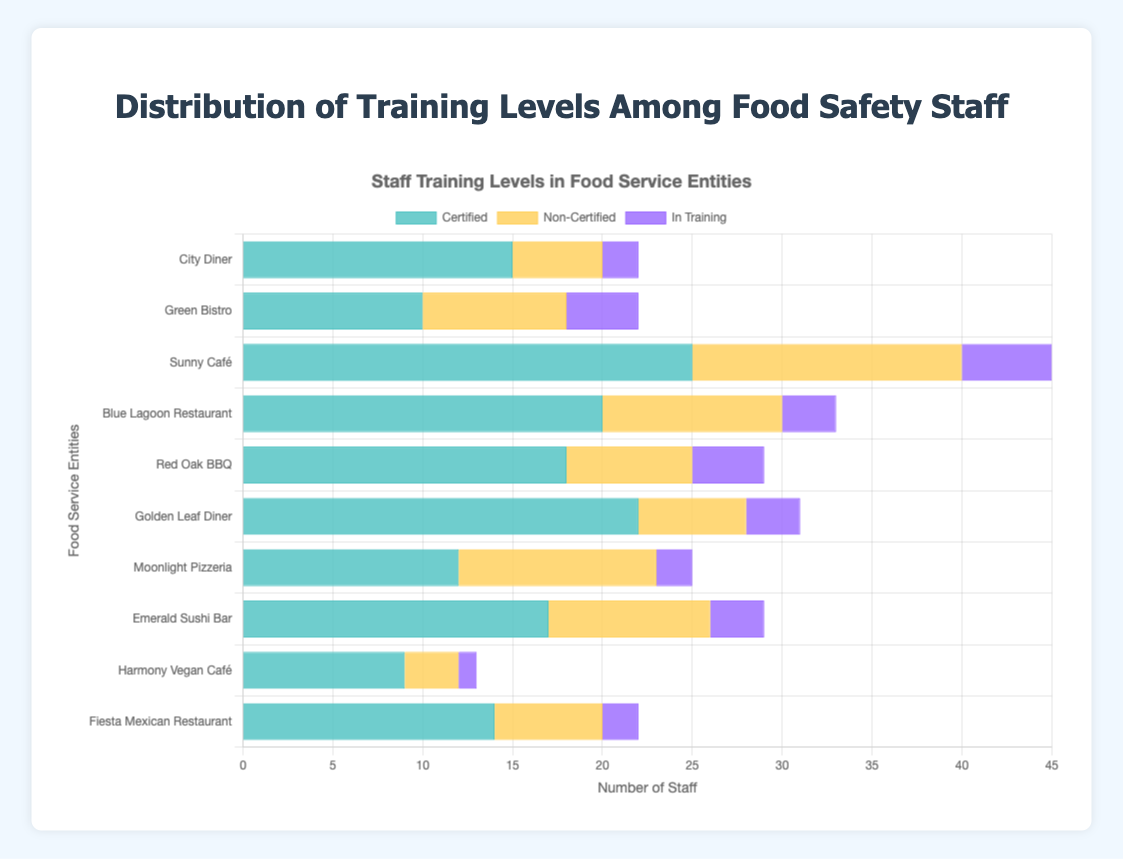What is the total number of certified staff across all food service entities? To find the total number of certified staff, sum the certified staff from all entities: 15 (City Diner) + 10 (Green Bistro) + 25 (Sunny Café) + 20 (Blue Lagoon Restaurant) + 18 (Red Oak BBQ) + 22 (Golden Leaf Diner) + 12 (Moonlight Pizzeria) + 17 (Emerald Sushi Bar) + 9 (Harmony Vegan Café) + 14 (Fiesta Mexican Restaurant) = 162
Answer: 162 Which food service entity has the highest compliance with best practices? Look at all the compliance percentages and identify the highest one, which belongs to Sunny Café at 95%.
Answer: Sunny Café For Green Bistro, what is the difference between the number of certified and non-certified staff? Subtract the number of non-certified staff from the number of certified staff for Green Bistro: 10 (certified) - 8 (non-certified) = 2
Answer: 2 Among the listed food service entities, which one has the least number of in-training staff? By comparing the in-training staff numbers, Harmony Vegan Café has the least with just 1 in-training staff.
Answer: Harmony Vegan Café What is the total staff count for City Diner? Sum the certified, non-certified, and in-training staff for City Diner: 15 (certified) + 5 (non-certified) + 2 (in-training) = 22
Answer: 22 Which food service entity has the greatest number of non-certified staff? Identify the highest number of non-certified staff: Sunny Café with 15 non-certified staff.
Answer: Sunny Café What is the average compliance percentage with best practices across all food service entities? Sum the compliance percentages and divide by the number of entities: (90 + 85 + 95 + 88 + 92 + 89 + 80 + 86 + 93 + 87) / 10 = 885 / 10 = 88.5
Answer: 88.5 What is the total number of staff (all categories) for Blue Lagoon Restaurant? Sum the certified, non-certified, and in-training staff for Blue Lagoon Restaurant: 20 (certified) + 10 (non-certified) + 3 (in-training) = 33
Answer: 33 Compare the number of in-training staff between Red Oak BBQ and Golden Leaf Diner. Which one has more and by how much? Subtract the in-training staff of Red Oak BBQ from Golden Leaf Diner: 4 (Red Oak BBQ) - 3 (Golden Leaf Diner) = 1. Red Oak BBQ has more by 1.
Answer: Red Oak BBQ, 1 How does the number of certified staff at Moonlight Pizzeria compare with City Diner? Moonlight Pizzeria has 12 certified staff, while City Diner has 15. Thus, City Diner has 3 more certified staff.
Answer: City Diner, 3 